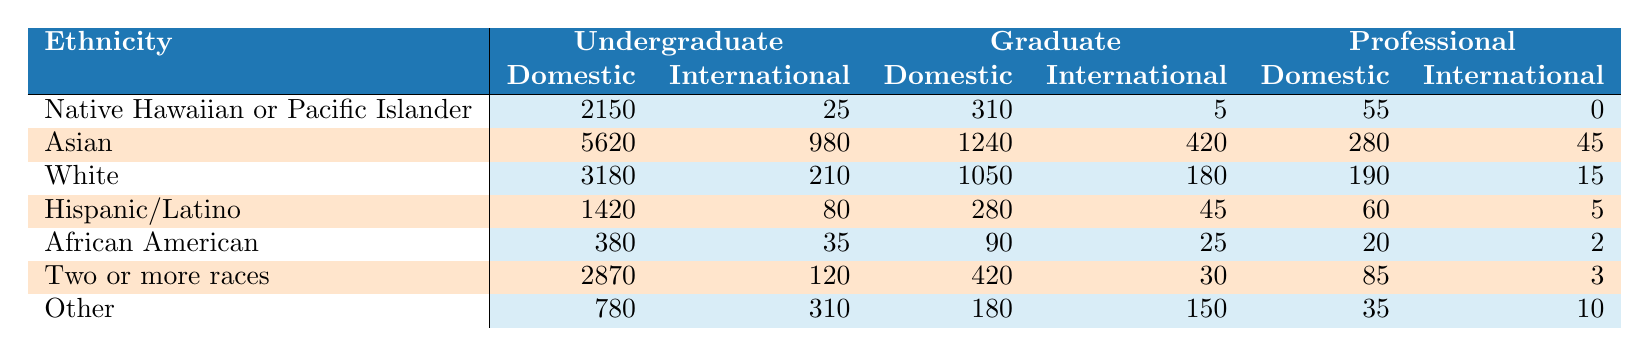What is the total number of domestic undergraduate students identified as Asian? According to the table, the number of domestic undergraduate students who are Asian is listed directly as 5620.
Answer: 5620 How many graduate students from the ethnicity of Hispanic/Latino are international students? The table shows that there are 45 graduate students from the ethnicity of Hispanic/Latino who are classified as international.
Answer: 45 Which ethnicity has the highest number of professional domestic students? By reviewing the table, the highest number of professional domestic students is 280 for the Asian ethnicity.
Answer: Asian How many more undergraduate domestic students are there for Native Hawaiian or Pacific Islander compared to African American? The number of undergraduate domestic students for Native Hawaiian or Pacific Islander is 2150, while for African American it is 380. The difference is calculated as 2150 - 380 = 1770.
Answer: 1770 What is the combined total of undergraduate international students for all ethnicities? Adding the international undergraduate students from each ethnicity: 25 (Native Hawaiian or Pacific Islander) + 980 (Asian) + 210 (White) + 80 (Hispanic/Latino) + 35 (African American) + 120 (Two or more races) + 310 (Other) = 1760.
Answer: 1760 Is the number of international professional students greater than 30? The total number of international professional students is 0 (Native Hawaiian or Pacific Islander) + 45 (Asian) + 15 (White) + 5 (Hispanic/Latino) + 2 (African American) + 3 (Two or more races) + 10 (Other) = 80, which is greater than 30.
Answer: Yes For which ethnicity do undergraduate international students outnumber graduate international students? According to the table, both Asian and Other ethnicities have more undergraduate international students (Asian: 980, Other: 310) than graduate international students (Asian: 420, Other: 150).
Answer: Asian and Other What is the difference between the total number of domestic and international students for the White ethnicity in the graduate category? The total number of domestic graduate students for the White ethnicity is 1050, and the total for international is 180. The difference is calculated as 1050 - 180 = 870.
Answer: 870 Which ethnicity has the least number of undergraduate domestic students? From the table, African American has the least number of undergraduate domestic students, totaling 380.
Answer: African American If you combine all the student counts for the Two or more races ethnicity, how many students are there in total? The total for Two or more races includes undergraduate domestic (2870) + undergraduate international (120) + graduate domestic (420) + graduate international (30) + professional domestic (85) + professional international (3). This sums to 3588.
Answer: 3588 